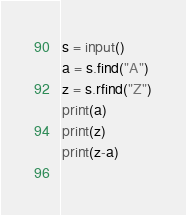<code> <loc_0><loc_0><loc_500><loc_500><_Python_>s = input()
a = s.find("A")
z = s.rfind("Z")
print(a)
print(z)
print(z-a)
    </code> 